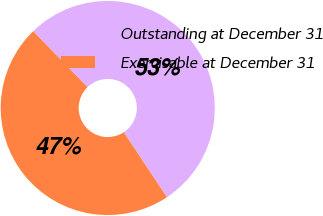Convert chart. <chart><loc_0><loc_0><loc_500><loc_500><pie_chart><fcel>Outstanding at December 31<fcel>Exercisable at December 31<nl><fcel>52.95%<fcel>47.05%<nl></chart> 